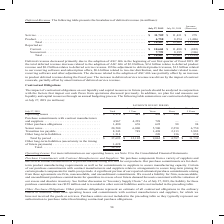According to Cisco Systems's financial document, What was the main reason for the decrease in revenue? due to the adoption of ASC 606 in the beginning of our first quarter of fiscal 2019.. The document states: "Deferred revenue decreased primarily due to the adoption of ASC 606 in the beginning of our first quarter of fiscal 2019. Of the total deferred revenu..." Also, Why did deferred service revenue increase? driven by the impact of contract renewals, partially offset by amortization of deferred service revenue.. The document states: "year. The increase in deferred service revenue was driven by the impact of contract renewals, partially offset by amortization of deferred service rev..." Also, Which years does the table provide information for the breakdown of the company's deferred revenue? The document shows two values: 2019 and 2018. From the document: "July 27, 2019 July 28, 2018 Increase (Decrease) July 27, 2019 July 28, 2018 Increase (Decrease)..." Also, can you calculate: What was the percentage change in service revenue between 2018 and 2019? To answer this question, I need to perform calculations using the financial data. The calculation is: (11,709-11,431)/11,431, which equals 2.43 (percentage). This is based on the information: "Service . $ 11,709 $ 11,431 $ 278 Product. . 6,758 8,254 (1,496) Total . $ 18,467 $ 19,685 $ (1,218) Reported as: Curr Service . $ 11,709 $ 11,431 $ 278 Product. . 6,758 8,254 (1,496) Total . $ 18,467..." The key data points involved are: 11,431, 11,709. Also, How many years did total reported deferred revenue exceed $15,000 million? Counting the relevant items in the document: 2019, 2018, I find 2 instances. The key data points involved are: 2018, 2019. Also, can you calculate: What was the percentage change in the total product revenue between 2018 and 2019? To answer this question, I need to perform calculations using the financial data. The calculation is: (6,758-8,254)/8,254, which equals -18.12 (percentage). This is based on the information: "Service . $ 11,709 $ 11,431 $ 278 Product. . 6,758 8,254 (1,496) Total . $ 18,467 $ 19,685 $ (1,218) Reported as: Current . $ 10,668 $ 11,490 $ (822) ervice . $ 11,709 $ 11,431 $ 278 Product. . 6,758 ..." The key data points involved are: 6,758, 8,254. 